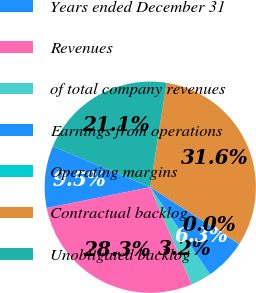Convert chart to OTSL. <chart><loc_0><loc_0><loc_500><loc_500><pie_chart><fcel>Years ended December 31<fcel>Revenues<fcel>of total company revenues<fcel>Earnings from operations<fcel>Operating margins<fcel>Contractual backlog<fcel>Unobligated backlog<nl><fcel>9.49%<fcel>28.26%<fcel>3.18%<fcel>6.34%<fcel>0.03%<fcel>31.56%<fcel>21.14%<nl></chart> 